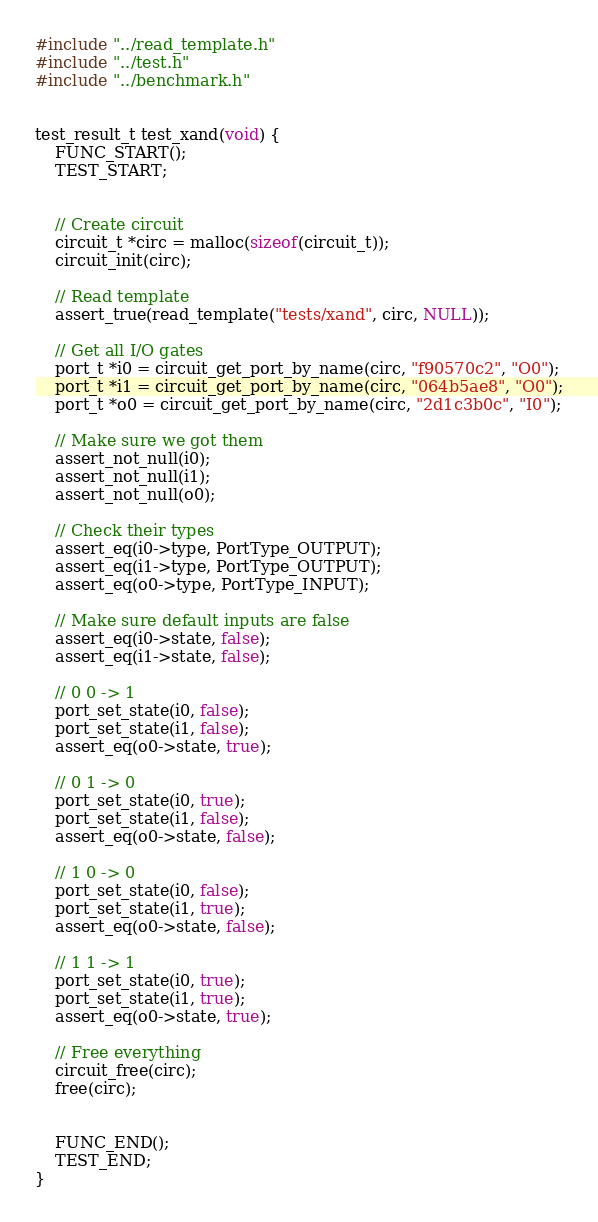<code> <loc_0><loc_0><loc_500><loc_500><_C_>#include "../read_template.h"
#include "../test.h"
#include "../benchmark.h"


test_result_t test_xand(void) {
	FUNC_START();
	TEST_START;


	// Create circuit
	circuit_t *circ = malloc(sizeof(circuit_t));
	circuit_init(circ);

	// Read template
	assert_true(read_template("tests/xand", circ, NULL));

	// Get all I/O gates
	port_t *i0 = circuit_get_port_by_name(circ, "f90570c2", "O0");
	port_t *i1 = circuit_get_port_by_name(circ, "064b5ae8", "O0");
	port_t *o0 = circuit_get_port_by_name(circ, "2d1c3b0c", "I0");

	// Make sure we got them
	assert_not_null(i0);
	assert_not_null(i1);
	assert_not_null(o0);

	// Check their types
	assert_eq(i0->type, PortType_OUTPUT);
	assert_eq(i1->type, PortType_OUTPUT);
	assert_eq(o0->type, PortType_INPUT);

	// Make sure default inputs are false
	assert_eq(i0->state, false);
	assert_eq(i1->state, false);

	// 0 0 -> 1
	port_set_state(i0, false);
	port_set_state(i1, false);
	assert_eq(o0->state, true);

	// 0 1 -> 0
	port_set_state(i0, true);
	port_set_state(i1, false);
	assert_eq(o0->state, false);

	// 1 0 -> 0
	port_set_state(i0, false);
	port_set_state(i1, true);
	assert_eq(o0->state, false);

	// 1 1 -> 1
	port_set_state(i0, true);
	port_set_state(i1, true);
	assert_eq(o0->state, true);

	// Free everything
	circuit_free(circ);
	free(circ);


	FUNC_END();
	TEST_END;
}
</code> 